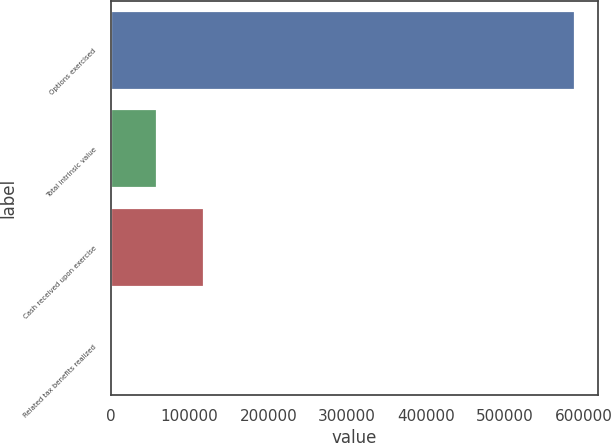<chart> <loc_0><loc_0><loc_500><loc_500><bar_chart><fcel>Options exercised<fcel>Total intrinsic value<fcel>Cash received upon exercise<fcel>Related tax benefits realized<nl><fcel>589081<fcel>58914.4<fcel>117822<fcel>7<nl></chart> 